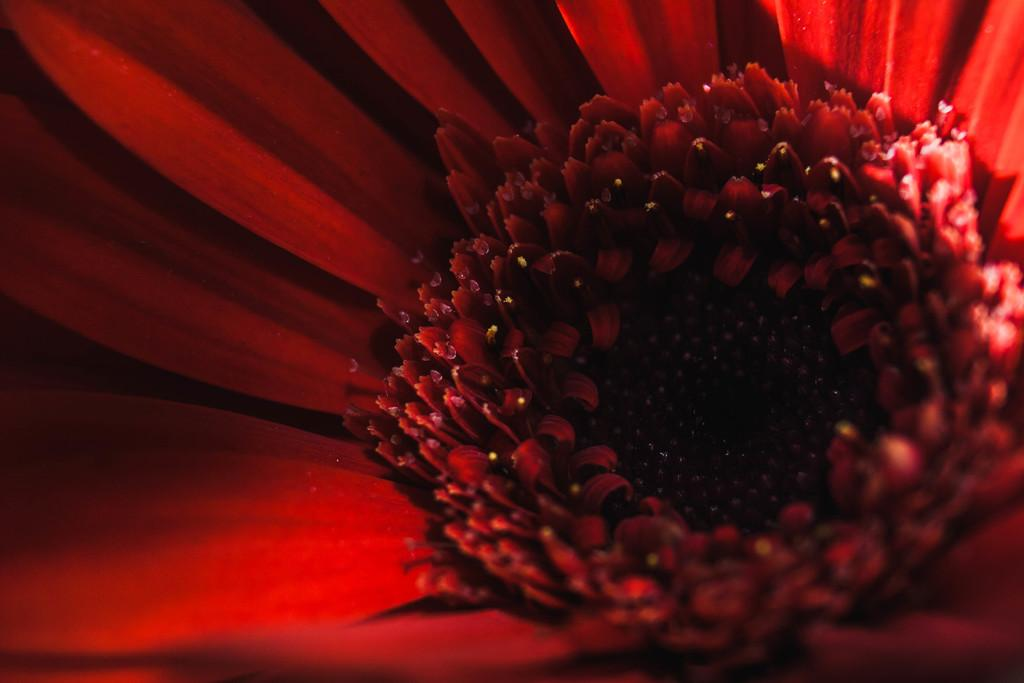What type of flower is present in the image? There is a red color flower in the image. Can you see the parent of the flower in the image? There is no parent of the flower visible in the image, as the focus is solely on the flower itself. 